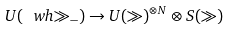<formula> <loc_0><loc_0><loc_500><loc_500>U ( \ w h { \gg } _ { - } ) \to U ( \gg ) ^ { \otimes N } \otimes S ( \gg )</formula> 